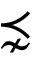Convert formula to latex. <formula><loc_0><loc_0><loc_500><loc_500>\precnsim</formula> 